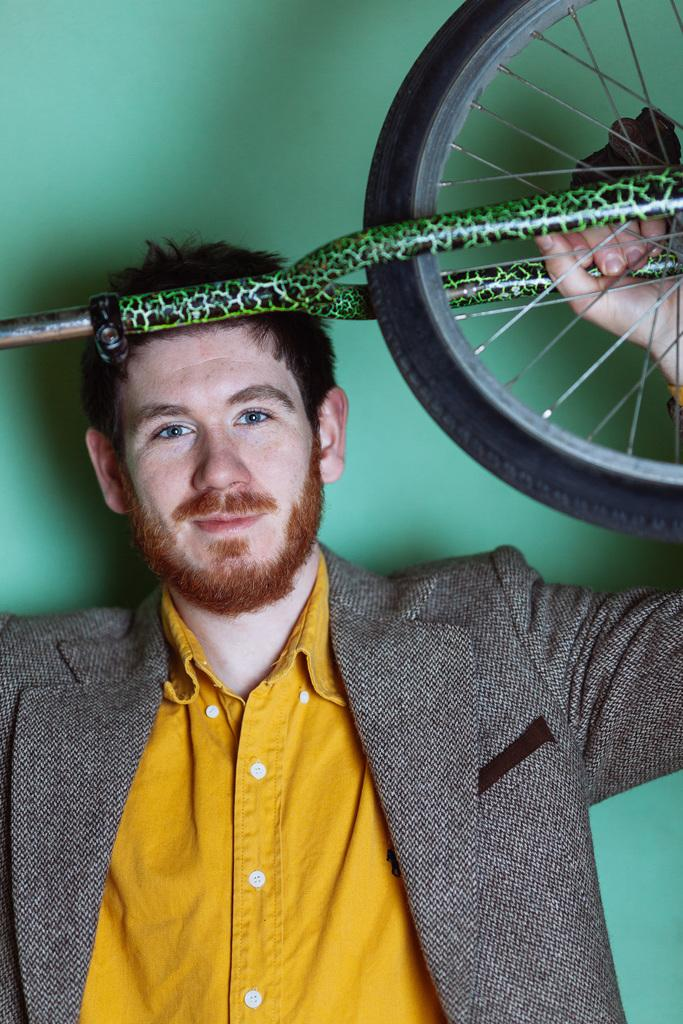What is the main subject of the image? The main subject of the image is a man. Can you describe the man's position in the image? The man is in the center of the image. What is the man holding in his hands? The man is holding a bicycle in his hands. What type of seed can be seen sprouting in the image? There is no seed present in the image. What season is depicted in the image? The provided facts do not mention any season or time of year. 